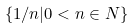<formula> <loc_0><loc_0><loc_500><loc_500>\{ 1 / n | 0 < n \in N \}</formula> 